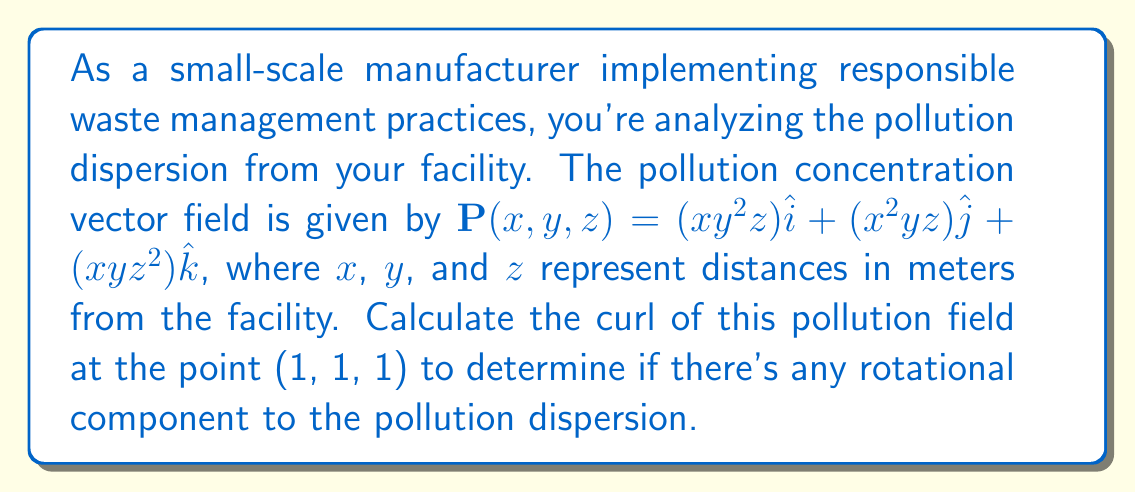Show me your answer to this math problem. To evaluate the curl of the pollution dispersion field, we'll use the curl formula in Cartesian coordinates:

$$\text{curl } \mathbf{P} = \nabla \times \mathbf{P} = \left(\frac{\partial P_z}{\partial y} - \frac{\partial P_y}{\partial z}\right)\hat{i} + \left(\frac{\partial P_x}{\partial z} - \frac{\partial P_z}{\partial x}\right)\hat{j} + \left(\frac{\partial P_y}{\partial x} - \frac{\partial P_x}{\partial y}\right)\hat{k}$$

Where:
$P_x = xy^2z$
$P_y = x^2yz$
$P_z = xyz^2$

Step 1: Calculate the partial derivatives:
$\frac{\partial P_z}{\partial y} = xz^2$
$\frac{\partial P_y}{\partial z} = x^2y$
$\frac{\partial P_x}{\partial z} = xy^2$
$\frac{\partial P_z}{\partial x} = yz^2$
$\frac{\partial P_y}{\partial x} = 2xyz$
$\frac{\partial P_x}{\partial y} = 2xyz$

Step 2: Substitute these into the curl formula:
$$\text{curl } \mathbf{P} = (xz^2 - x^2y)\hat{i} + (xy^2 - yz^2)\hat{j} + (2xyz - 2xyz)\hat{k}$$

Step 3: Simplify:
$$\text{curl } \mathbf{P} = (xz^2 - x^2y)\hat{i} + (xy^2 - yz^2)\hat{j} + 0\hat{k}$$

Step 4: Evaluate at the point (1, 1, 1):
$$\text{curl } \mathbf{P}(1,1,1) = (1^2 - 1^2)\hat{i} + (1^2 - 1^2)\hat{j} + 0\hat{k} = 0\hat{i} + 0\hat{j} + 0\hat{k}$$
Answer: $\text{curl } \mathbf{P}(1,1,1) = \mathbf{0}$ 